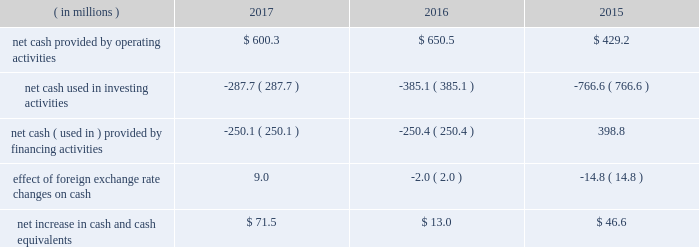Our operating cash flows are significantly impacted by the seasonality of our businesses .
We typically generate most of our operating cash flow in the third and fourth quarters of each year .
In june 2015 , we issued $ 900 million of senior notes in a registered public offering .
The senior notes consist of two tranches : $ 400 million of five-year notes due 2020 with a coupon of 3% ( 3 % ) and $ 500 million of ten-year notes due 2025 with a coupon of 4% ( 4 % ) .
We used the proceeds from the senior notes offering to pay down our revolving credit facility and for general corporate purposes .
On december 31 , 2017 , the outstanding amount of the senior notes , net of underwriting commissions and price discounts , was $ 892.6 million .
Cash flows below is a summary of cash flows for the years ended december 31 , 2017 , 2016 and 2015 .
( in millions ) 2017 2016 2015 .
Net cash provided by operating activities was $ 600.3 million in 2017 compared to $ 650.5 million in 2016 and $ 429.2 million in 2015 .
The $ 50.2 million decrease in cash provided by operating activities from 2017 to 2016 was primarily due to higher build in working capital , primarily driven by higher inventory purchases in 2017 , partially offset by a higher net income .
The $ 221.3 million increase in cash provided by operating activities from 2015 to 2016 was primarily due to a reduction in working capital in 2016 compared to 2015 and higher net income .
Net cash used in investing activities was $ 287.7 million in 2017 compared to $ 385.1 million in 2016 and $ 766.6 million in 2015 .
The decrease of $ 97.4 million from 2016 to 2017 was primarily due lower cost of acquisitions of $ 115.1 million , partially offset by $ 15.7 million of higher capital expenditures .
The decrease of $ 381.5 million from 2015 to 2016 was primarily due the decrease in cost of acquisitions of $ 413.1 million , partially offset by $ 20.8 million of higher capital spending .
Net cash used in financing activities was $ 250.1 million in 2017 compared to net cash used in financing activities of $ 250.4 million in 2016 and net cash provided by in financing activities of $ 398.8 million in 2015 .
The change of $ 649.2 million in 2016 compared to 2015 was primarily due to $ 372.8 million of higher share repurchases and lower net borrowings of $ 240.8 million .
Pension plans subsidiaries of fortune brands sponsor their respective defined benefit pension plans that are funded by a portfolio of investments maintained within our benefit plan trust .
In 2017 , 2016 and 2015 , we contributed $ 28.4 million , zero and $ 2.3 million , respectively , to qualified pension plans .
In 2018 , we expect to make pension contributions of approximately $ 12.8 million .
As of december 31 , 2017 , the fair value of our total pension plan assets was $ 656.6 million , representing funding of 79% ( 79 % ) of the accumulated benefit obligation liability .
For the foreseeable future , we believe that we have sufficient liquidity to meet the minimum funding that may be required by the pension protection act of 2006 .
Foreign exchange we have operations in various foreign countries , principally canada , china , mexico , the united kingdom , france , australia and japan .
Therefore , changes in the value of the related currencies affect our financial statements when translated into u.s .
Dollars. .
What was the ratio of the net cash provided by operating activities to the net cash used in investing activities in 2017? 
Rationale: the company invested $ 1 for every $ 2.09 earned from operations
Computations: (600.3 / 287.7)
Answer: 2.08655. 